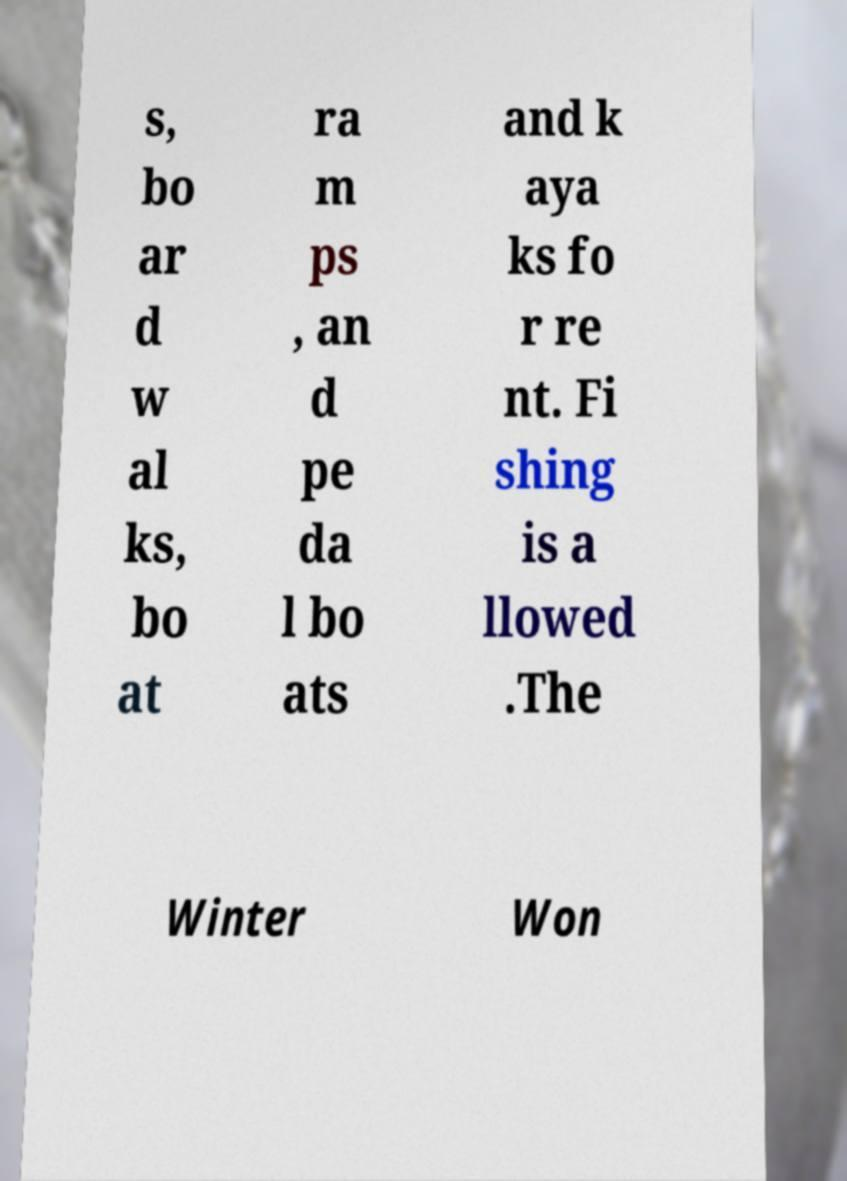Can you read and provide the text displayed in the image?This photo seems to have some interesting text. Can you extract and type it out for me? s, bo ar d w al ks, bo at ra m ps , an d pe da l bo ats and k aya ks fo r re nt. Fi shing is a llowed .The Winter Won 